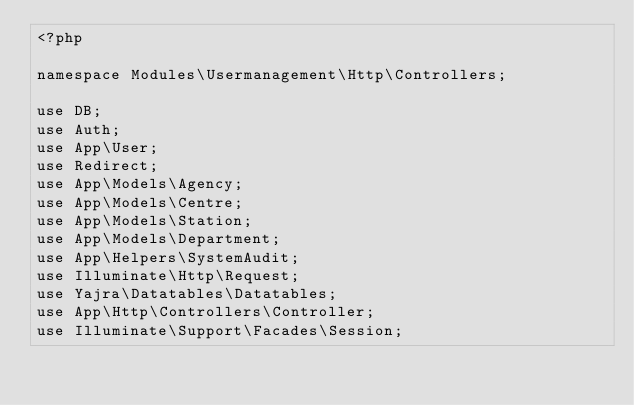<code> <loc_0><loc_0><loc_500><loc_500><_PHP_><?php

namespace Modules\Usermanagement\Http\Controllers;

use DB;
use Auth;
use App\User;
use Redirect;
use App\Models\Agency;
use App\Models\Centre;
use App\Models\Station;
use App\Models\Department;
use App\Helpers\SystemAudit;
use Illuminate\Http\Request;
use Yajra\Datatables\Datatables;
use App\Http\Controllers\Controller;
use Illuminate\Support\Facades\Session;</code> 